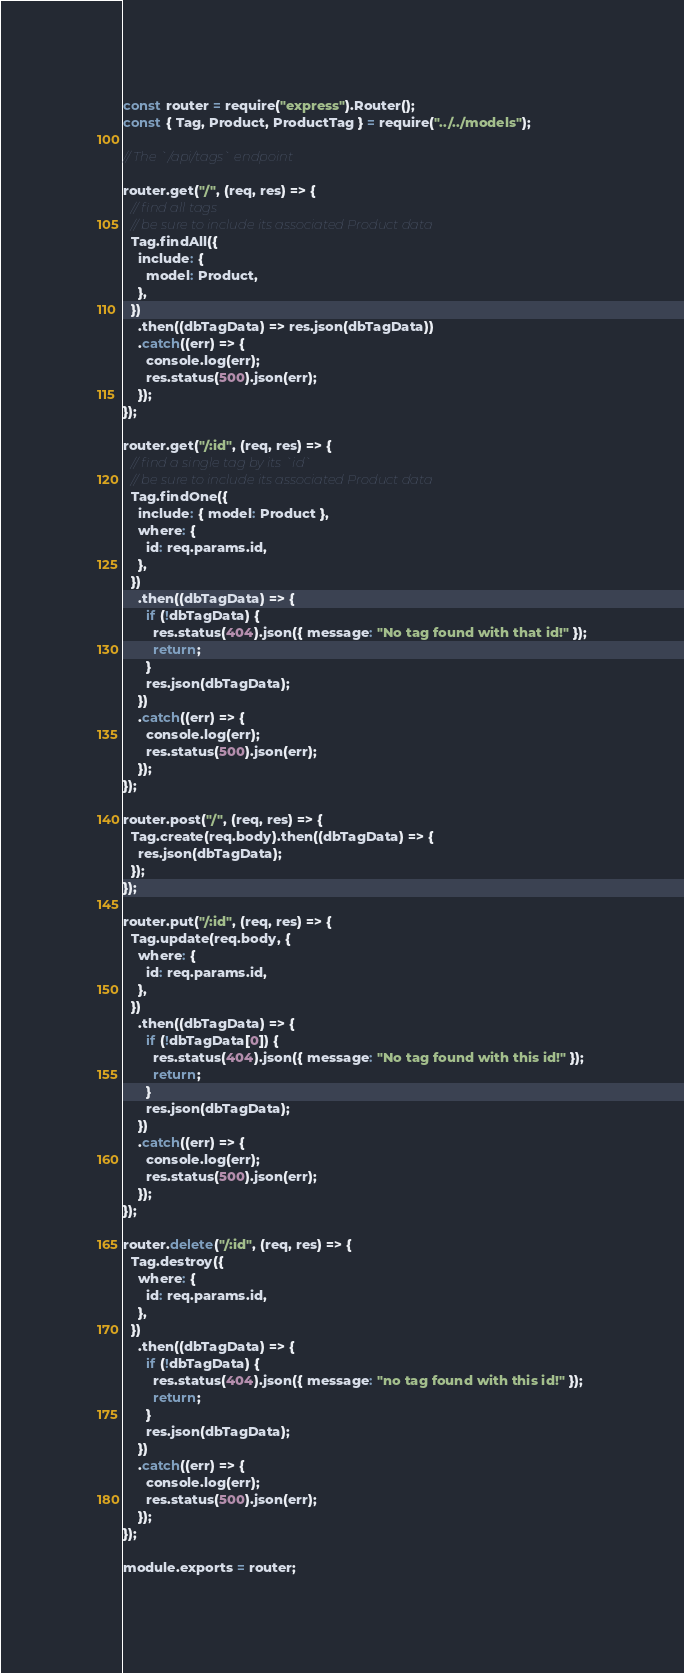<code> <loc_0><loc_0><loc_500><loc_500><_JavaScript_>const router = require("express").Router();
const { Tag, Product, ProductTag } = require("../../models");

// The `/api/tags` endpoint

router.get("/", (req, res) => {
  // find all tags
  // be sure to include its associated Product data
  Tag.findAll({
    include: {
      model: Product,
    },
  })
    .then((dbTagData) => res.json(dbTagData))
    .catch((err) => {
      console.log(err);
      res.status(500).json(err);
    });
});

router.get("/:id", (req, res) => {
  // find a single tag by its `id`
  // be sure to include its associated Product data
  Tag.findOne({
    include: { model: Product },
    where: {
      id: req.params.id,
    },
  })
    .then((dbTagData) => {
      if (!dbTagData) {
        res.status(404).json({ message: "No tag found with that id!" });
        return;
      }
      res.json(dbTagData);
    })
    .catch((err) => {
      console.log(err);
      res.status(500).json(err);
    });
});

router.post("/", (req, res) => {
  Tag.create(req.body).then((dbTagData) => {
    res.json(dbTagData);
  });
});

router.put("/:id", (req, res) => {
  Tag.update(req.body, {
    where: {
      id: req.params.id,
    },
  })
    .then((dbTagData) => {
      if (!dbTagData[0]) {
        res.status(404).json({ message: "No tag found with this id!" });
        return;
      }
      res.json(dbTagData);
    })
    .catch((err) => {
      console.log(err);
      res.status(500).json(err);
    });
});

router.delete("/:id", (req, res) => {
  Tag.destroy({
    where: {
      id: req.params.id,
    },
  })
    .then((dbTagData) => {
      if (!dbTagData) {
        res.status(404).json({ message: "no tag found with this id!" });
        return;
      }
      res.json(dbTagData);
    })
    .catch((err) => {
      console.log(err);
      res.status(500).json(err);
    });
});

module.exports = router;
</code> 